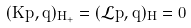Convert formula to latex. <formula><loc_0><loc_0><loc_500><loc_500>( K p , q ) _ { H _ { + } } = ( \mathcal { L } p , q ) _ { H } = 0</formula> 